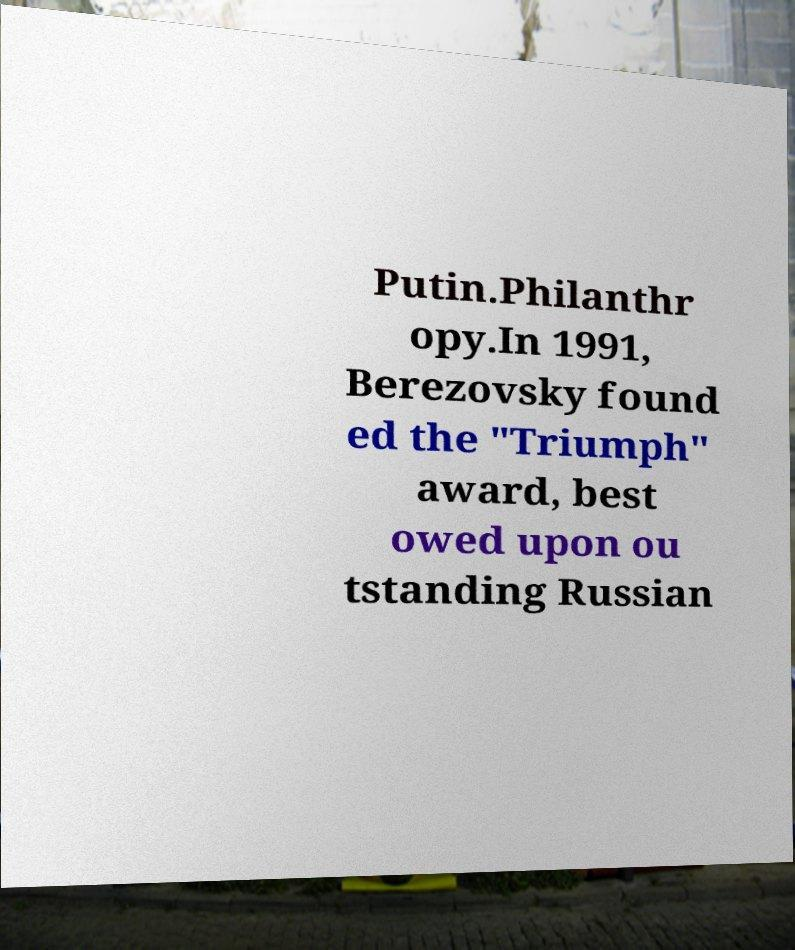Could you extract and type out the text from this image? Putin.Philanthr opy.In 1991, Berezovsky found ed the "Triumph" award, best owed upon ou tstanding Russian 